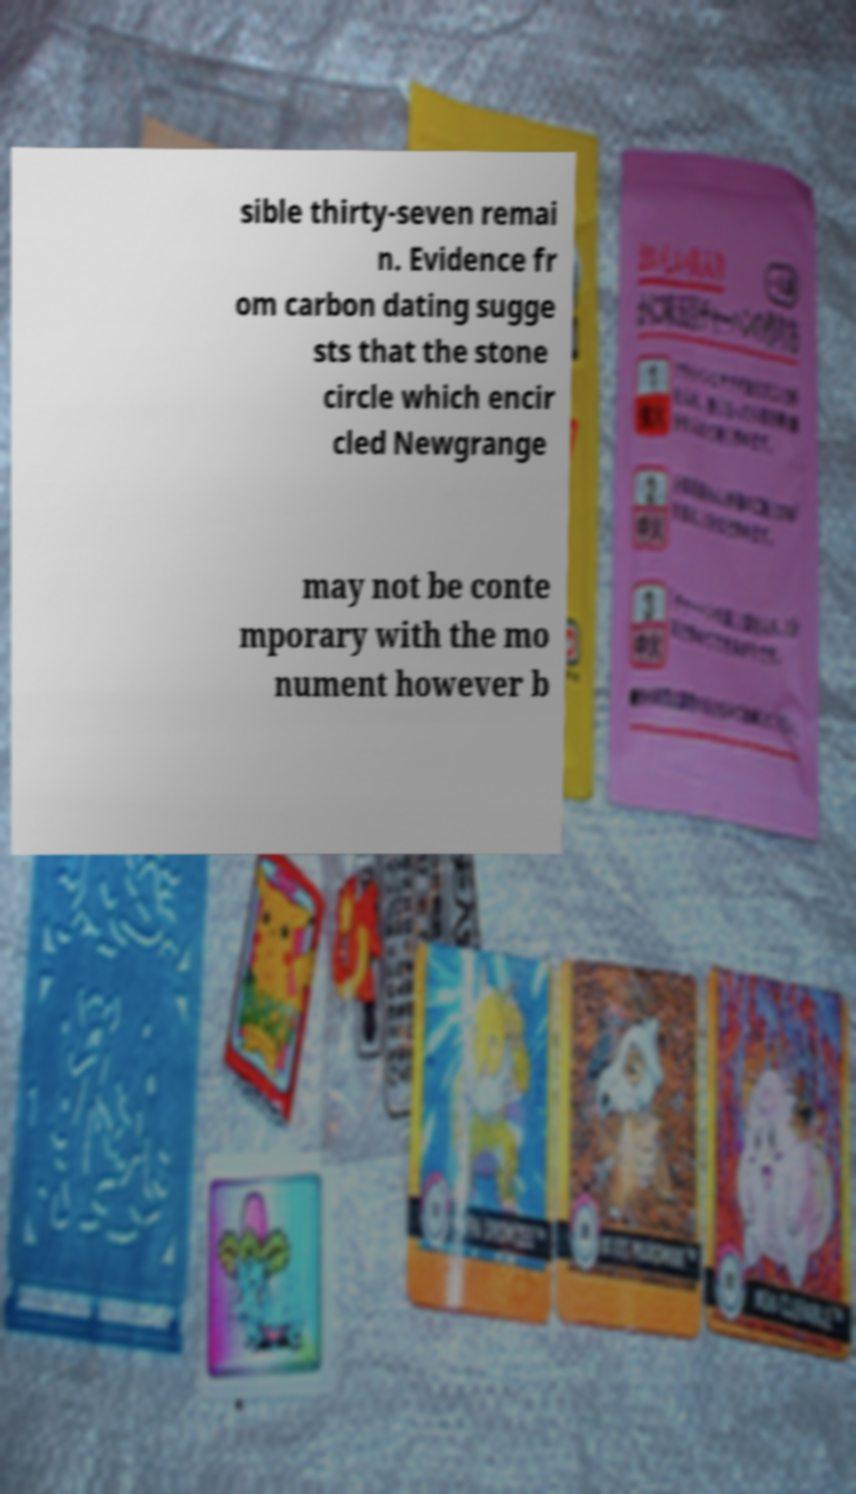What messages or text are displayed in this image? I need them in a readable, typed format. sible thirty-seven remai n. Evidence fr om carbon dating sugge sts that the stone circle which encir cled Newgrange may not be conte mporary with the mo nument however b 